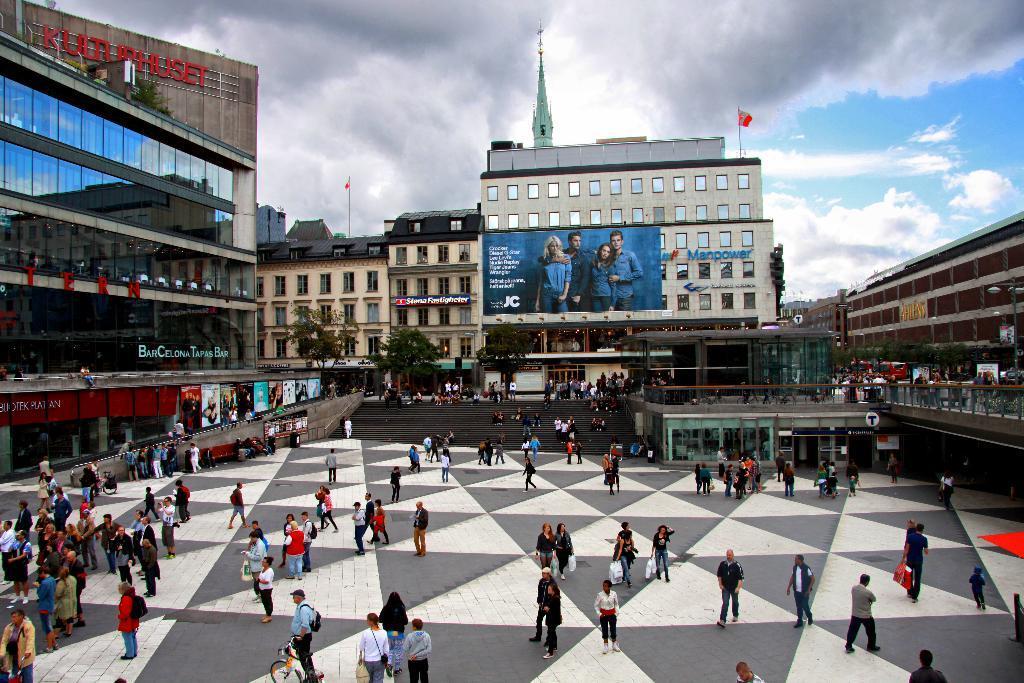Could you give a brief overview of what you see in this image? In this picture I can observe some people walking on the land. There are men and women in this picture. In the background I can observe buildings, trees and some clouds in the sky. 